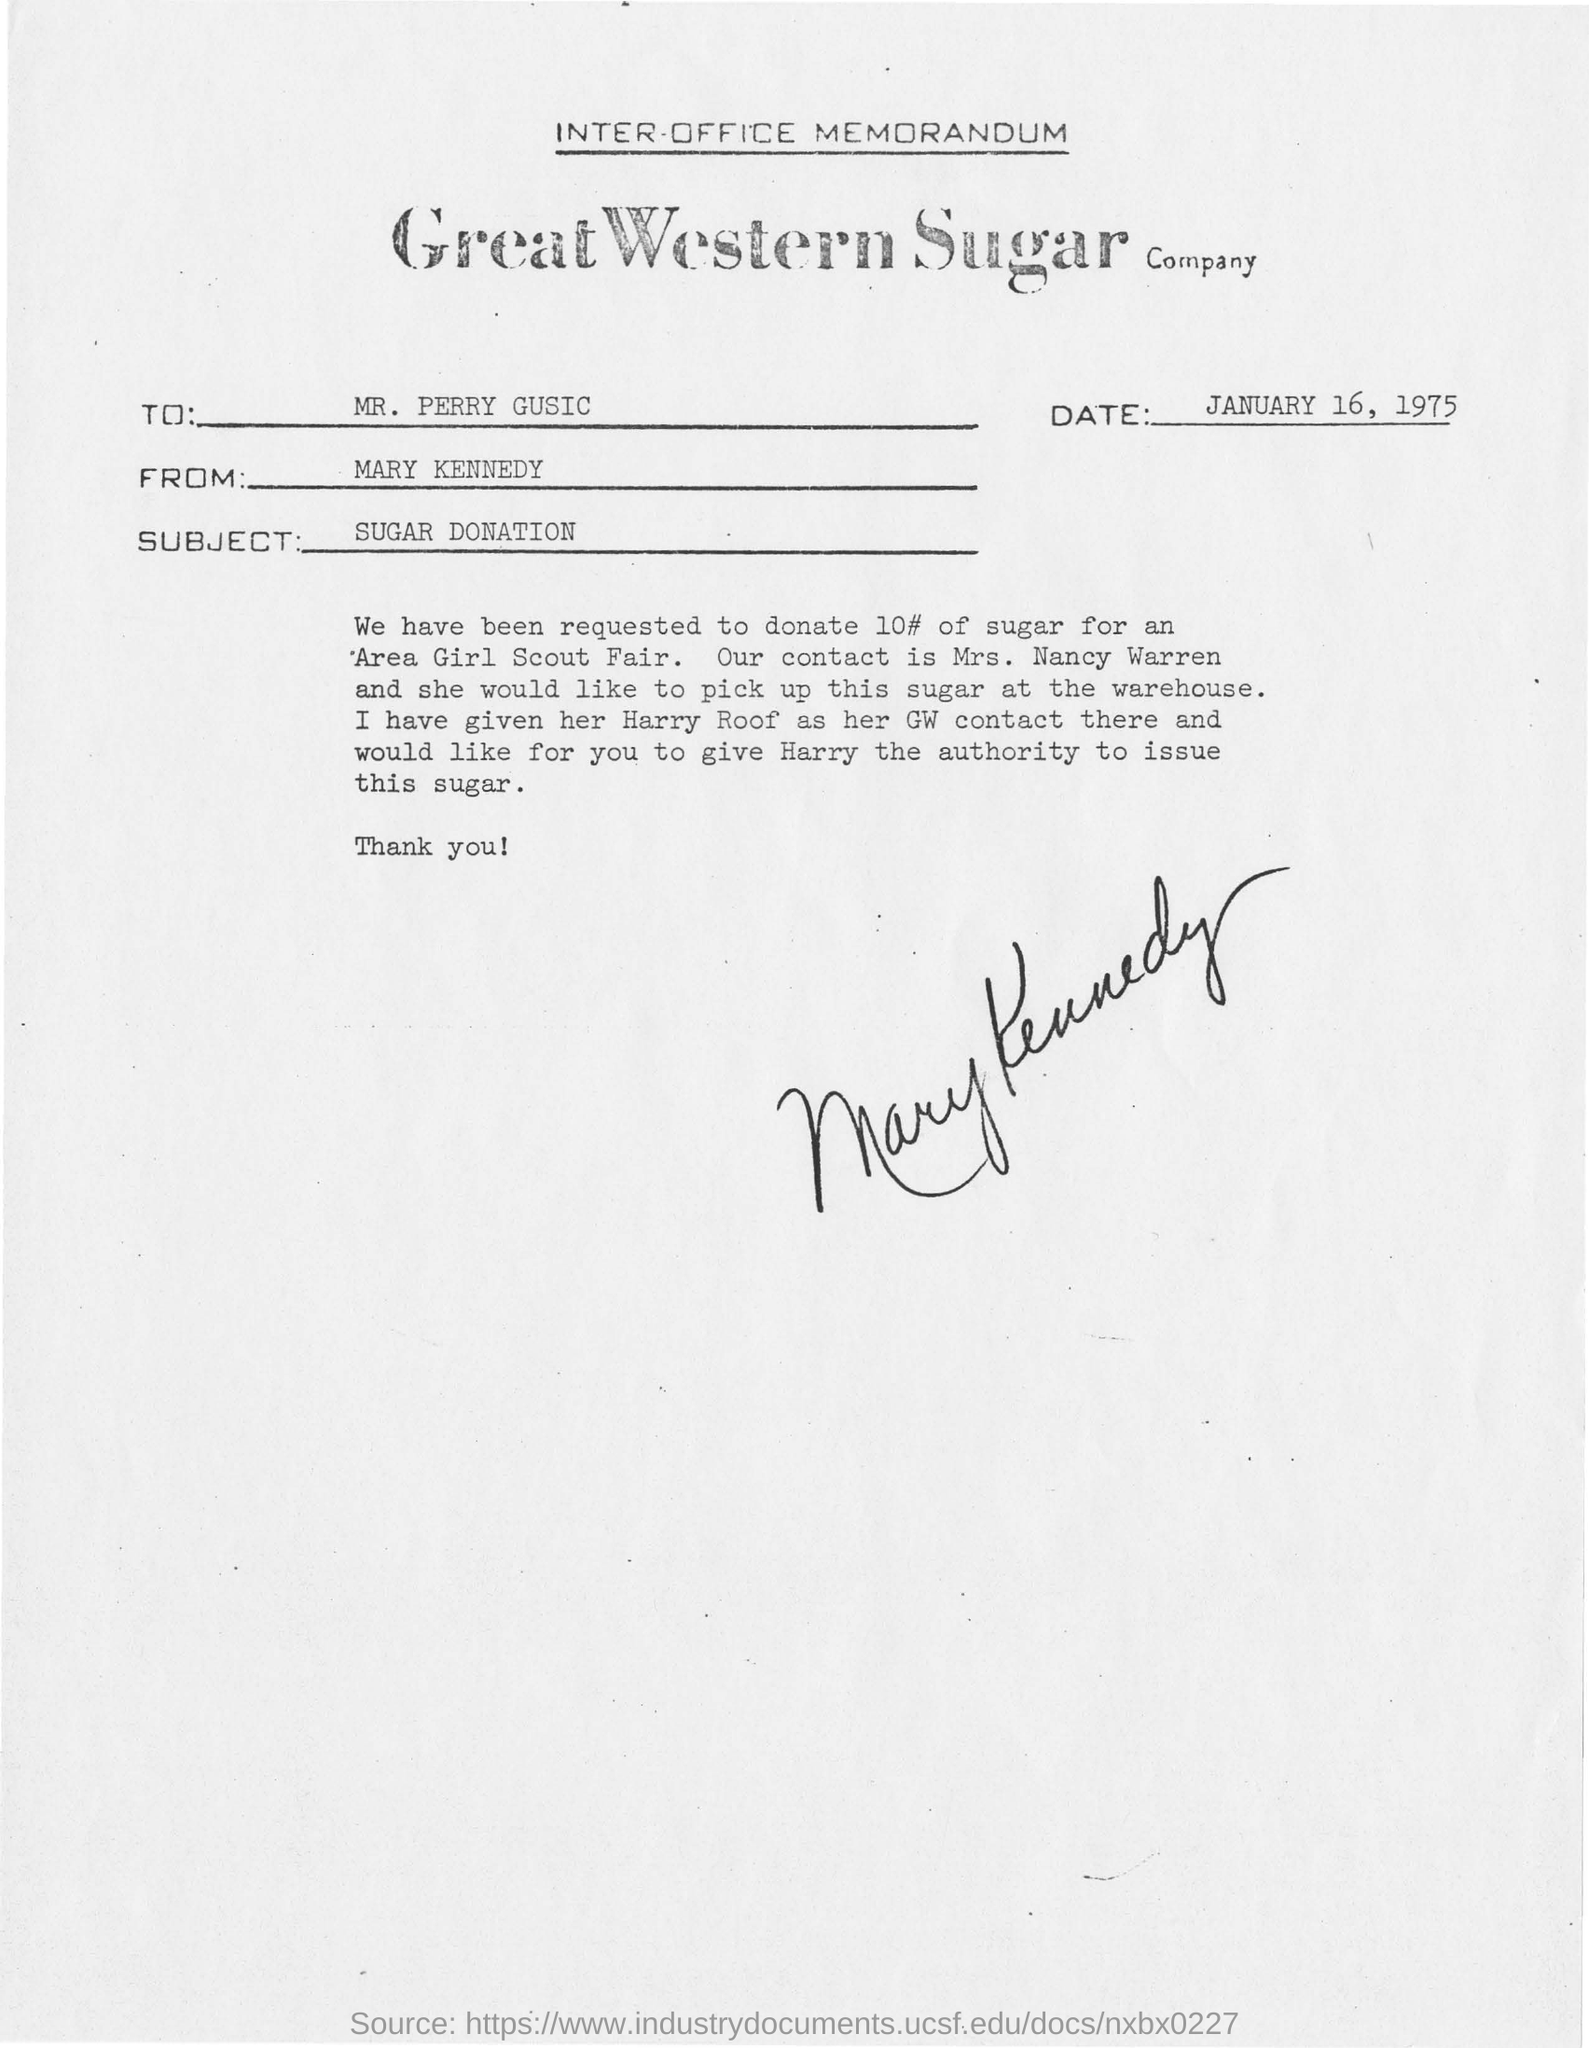Who is the memorandum from?
Give a very brief answer. Mary Kennedy. To Whom is this memorandum addressed to?
Provide a short and direct response. Mr. Perry Gusic. What is the subject of this memorandum?
Keep it short and to the point. SUGAR DONATION. 